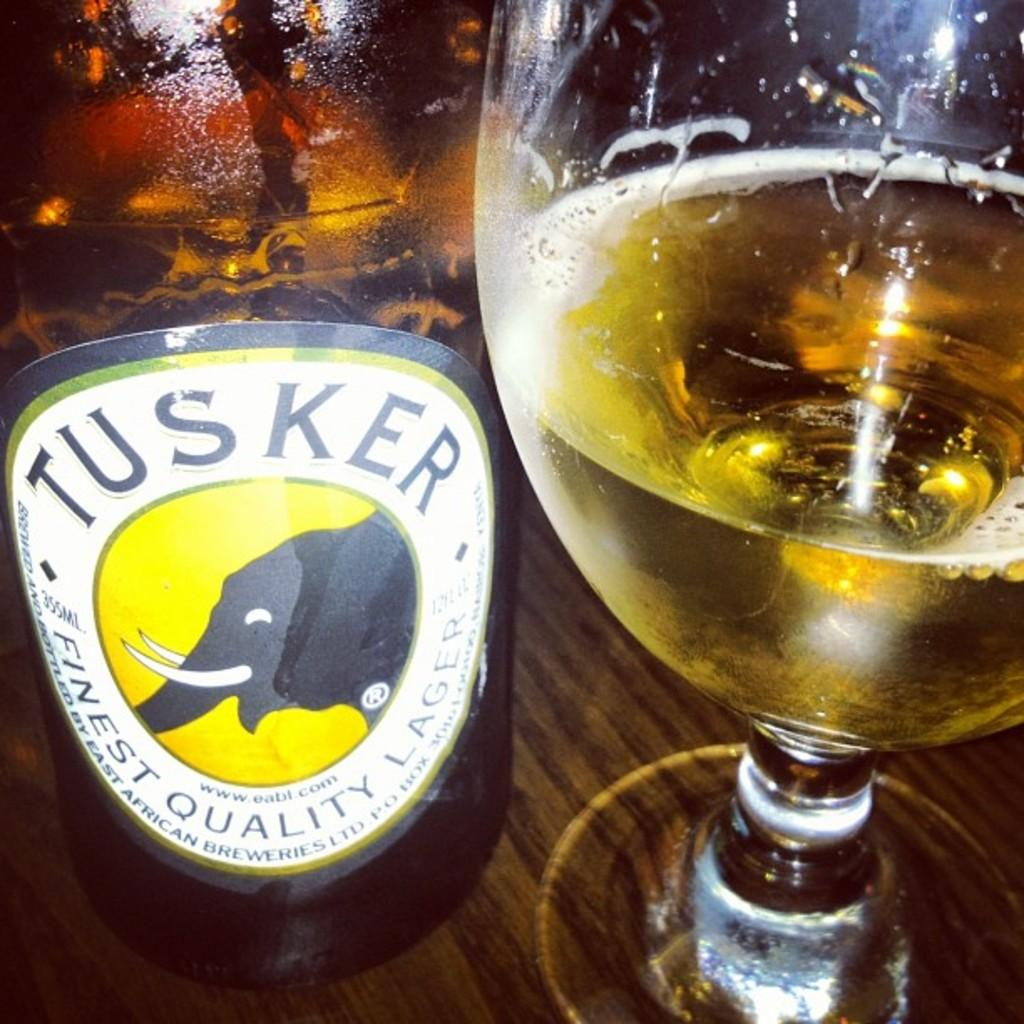<image>
Provide a brief description of the given image. A bottle of Tusker Lager is next to a glass. 